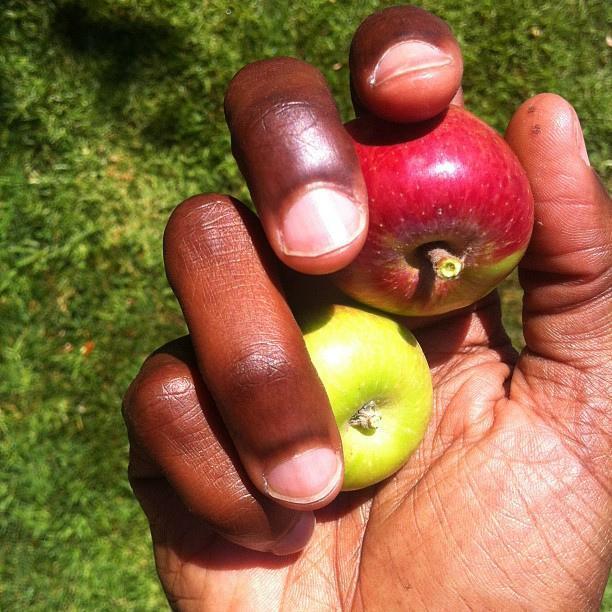What race is this person holding the apples?
Pick the right solution, then justify: 'Answer: answer
Rationale: rationale.'
Options: African, hispanic, east asian, white. Answer: african.
Rationale: The skin on the hand is very dark. 